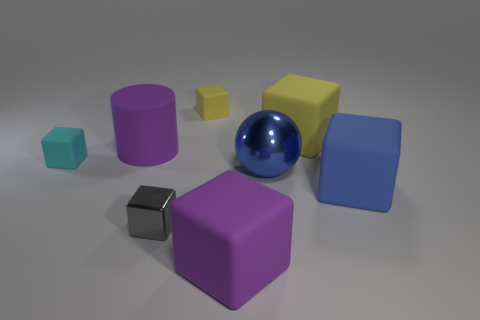How many purple matte blocks are right of the blue object that is to the left of the large blue rubber object?
Offer a very short reply. 0. What is the size of the cube that is on the right side of the tiny yellow thing and on the left side of the sphere?
Provide a short and direct response. Large. Are there any cyan matte cubes that have the same size as the blue rubber block?
Your answer should be very brief. No. Are there more big blue matte blocks to the right of the big blue block than big purple things that are behind the big cylinder?
Give a very brief answer. No. Is the material of the small cyan object the same as the purple thing that is on the left side of the tiny yellow rubber object?
Your answer should be very brief. Yes. How many things are behind the purple rubber object on the left side of the small block in front of the big blue shiny thing?
Give a very brief answer. 2. There is a tiny cyan object; is its shape the same as the purple object that is in front of the matte cylinder?
Give a very brief answer. Yes. There is a matte block that is both in front of the large metal sphere and behind the purple block; what color is it?
Ensure brevity in your answer.  Blue. There is a purple object to the right of the tiny thing that is behind the large purple rubber object that is behind the big blue shiny ball; what is it made of?
Ensure brevity in your answer.  Rubber. What is the tiny gray thing made of?
Provide a short and direct response. Metal. 